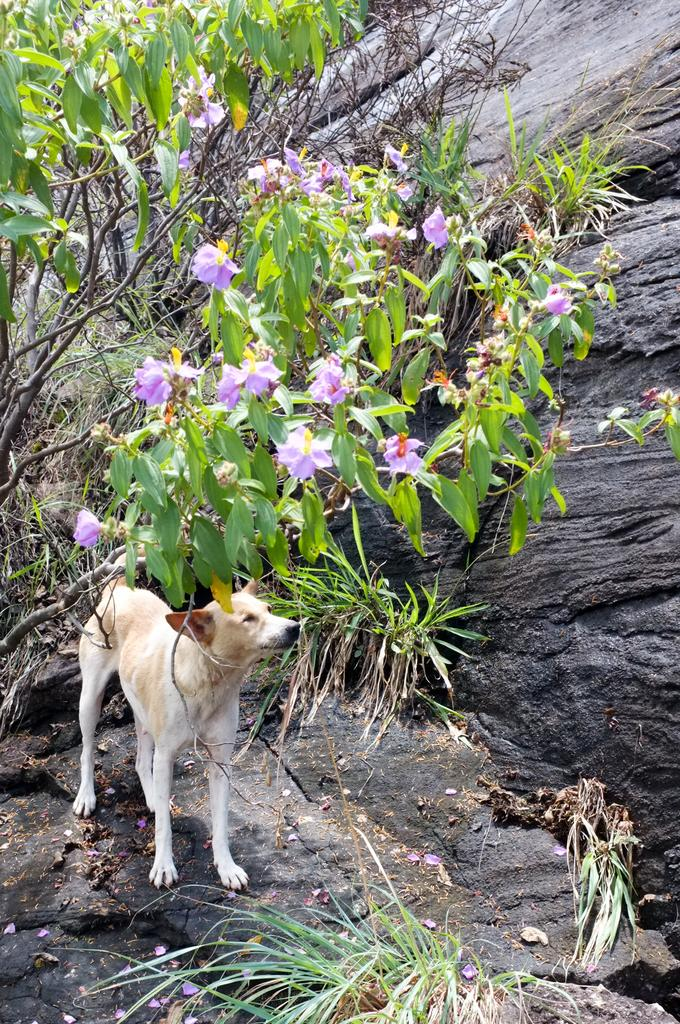What type of animal is in the image? There is a dog in the image. What is the dog doing in the image? The dog is standing on the ground. What can be seen in the background of the image? There are trees in the background of the image. What type of natural feature is on the right side of the image? There are rocks on the right side of the image. What type of produce is the dog holding in the image? There is no produce present in the image; the dog is not holding anything. 